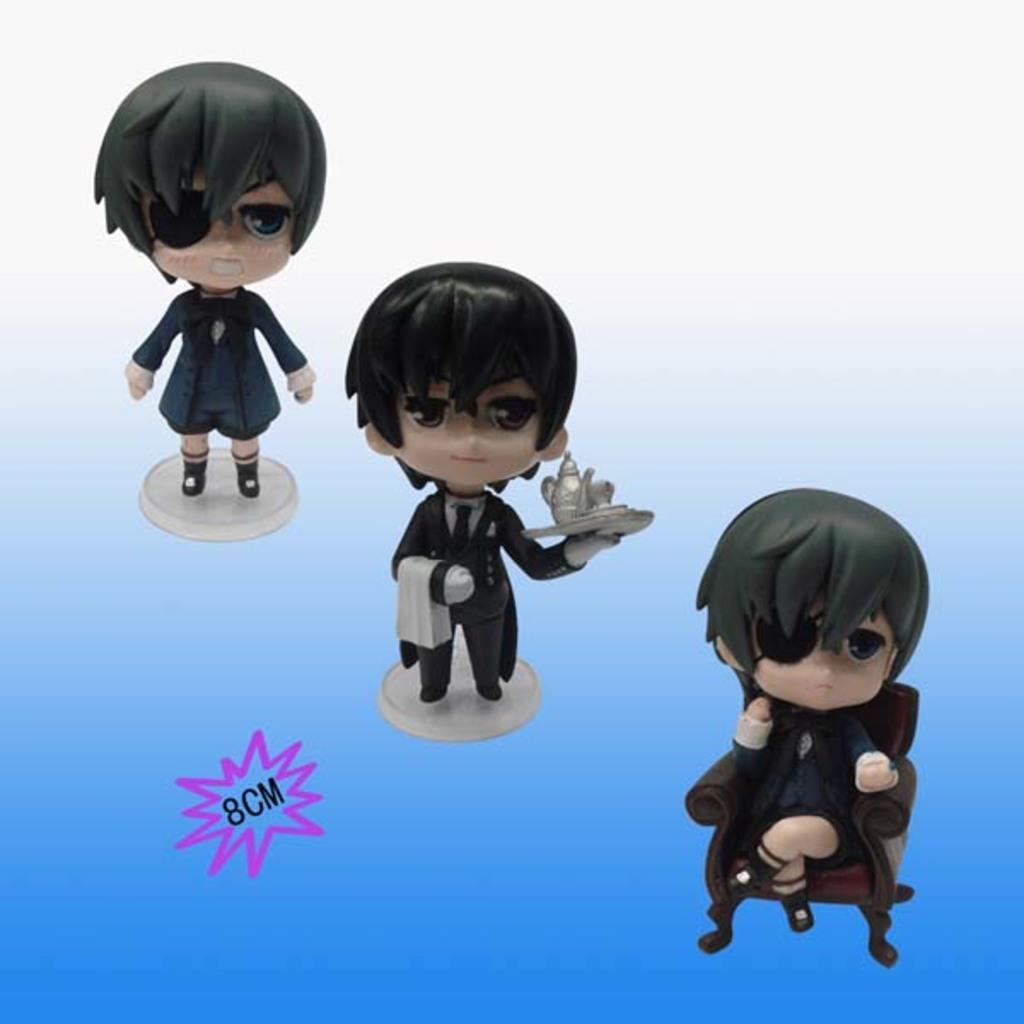Can you describe this image briefly? In this image we can see cartoons and there is some text. 